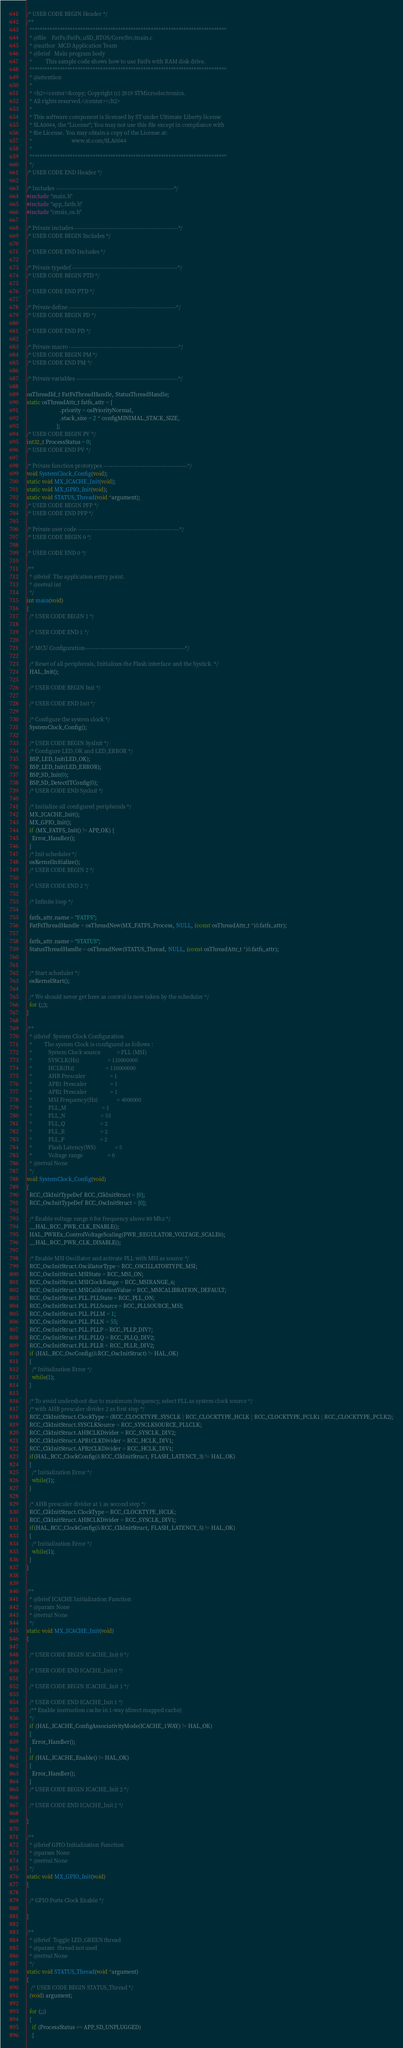<code> <loc_0><loc_0><loc_500><loc_500><_C_>/* USER CODE BEGIN Header */
/**
  ******************************************************************************
  * @file    FatFs/FatFs_uSD_RTOS/Core/Src/main.c
  * @author  MCD Application Team
  * @brief   Main program body
  *          This sample code shows how to use FatFs with RAM disk drive.
  ******************************************************************************
  * @attention
  *
  * <h2><center>&copy; Copyright (c) 2019 STMicroelectronics.
  * All rights reserved.</center></h2>
  *
  * This software component is licensed by ST under Ultimate Liberty license
  * SLA0044, the "License"; You may not use this file except in compliance with
  * the License. You may obtain a copy of the License at:
  *                             www.st.com/SLA0044
  *
  ******************************************************************************
  */
/* USER CODE END Header */

/* Includes ------------------------------------------------------------------*/
#include "main.h"
#include "app_fatfs.h"
#include "cmsis_os.h"

/* Private includes ----------------------------------------------------------*/
/* USER CODE BEGIN Includes */

/* USER CODE END Includes */

/* Private typedef -----------------------------------------------------------*/
/* USER CODE BEGIN PTD */

/* USER CODE END PTD */

/* Private define ------------------------------------------------------------*/
/* USER CODE BEGIN PD */

/* USER CODE END PD */

/* Private macro -------------------------------------------------------------*/
/* USER CODE BEGIN PM */
/* USER CODE END PM */

/* Private variables ---------------------------------------------------------*/

osThreadId_t FatFsThreadHandle, StatusThreadHandle;
static osThreadAttr_t fatfs_attr = {
                        .priority = osPriorityNormal,
                        .stack_size = 2 * configMINIMAL_STACK_SIZE,
                      };
/* USER CODE BEGIN PV */
int32_t ProcessStatus = 0;
/* USER CODE END PV */

/* Private function prototypes -----------------------------------------------*/
void SystemClock_Config(void);
static void MX_ICACHE_Init(void);
static void MX_GPIO_Init(void);
static void STATUS_Thread(void *argument);
/* USER CODE BEGIN PFP */
/* USER CODE END PFP */

/* Private user code ---------------------------------------------------------*/
/* USER CODE BEGIN 0 */

/* USER CODE END 0 */

/**
  * @brief  The application entry point.
  * @retval int
  */
int main(void)
{
  /* USER CODE BEGIN 1 */

  /* USER CODE END 1 */

  /* MCU Configuration--------------------------------------------------------*/

  /* Reset of all peripherals, Initializes the Flash interface and the Systick. */
  HAL_Init();

  /* USER CODE BEGIN Init */

  /* USER CODE END Init */

  /* Configure the system clock */
  SystemClock_Config();

  /* USER CODE BEGIN SysInit */
  /* Configure LED_OK and LED_ERROR */
  BSP_LED_Init(LED_OK);
  BSP_LED_Init(LED_ERROR);
  BSP_SD_Init(0);
  BSP_SD_DetectITConfig(0);
  /* USER CODE END SysInit */

  /* Initialize all configured peripherals */
  MX_ICACHE_Init();
  MX_GPIO_Init();
  if (MX_FATFS_Init() != APP_OK) {
    Error_Handler();
  }
  /* Init scheduler */
  osKernelInitialize();
  /* USER CODE BEGIN 2 */

  /* USER CODE END 2 */

  /* Infinite loop */

  fatfs_attr.name = "FATFS";
  FatFsThreadHandle = osThreadNew(MX_FATFS_Process, NULL, (const osThreadAttr_t *)&fatfs_attr);

  fatfs_attr.name = "STATUS";
  StatusThreadHandle = osThreadNew(STATUS_Thread, NULL, (const osThreadAttr_t *)&fatfs_attr);


  /* Start scheduler */
  osKernelStart();

  /* We should never get here as control is now taken by the scheduler */
  for (;;);
}

/**
  * @brief  System Clock Configuration
  *         The system Clock is configured as follows :
  *            System Clock source            = PLL (MSI)
  *            SYSCLK(Hz)                     = 110000000
  *            HCLK(Hz)                       = 110000000
  *            AHB Prescaler                  = 1
  *            APB1 Prescaler                 = 1
  *            APB2 Prescaler                 = 1
  *            MSI Frequency(Hz)              = 4000000
  *            PLL_M                          = 1
  *            PLL_N                          = 55
  *            PLL_Q                          = 2
  *            PLL_R                          = 2
  *            PLL_P                          = 2
  *            Flash Latency(WS)              = 5
  *            Voltage range                  = 0
  * @retval None
  */
void SystemClock_Config(void)
{
  RCC_ClkInitTypeDef RCC_ClkInitStruct = {0};
  RCC_OscInitTypeDef RCC_OscInitStruct = {0};

  /* Enable voltage range 0 for frequency above 80 Mhz */
  __HAL_RCC_PWR_CLK_ENABLE();
  HAL_PWREx_ControlVoltageScaling(PWR_REGULATOR_VOLTAGE_SCALE0);
  __HAL_RCC_PWR_CLK_DISABLE();

  /* Enable MSI Oscillator and activate PLL with MSI as source */
  RCC_OscInitStruct.OscillatorType = RCC_OSCILLATORTYPE_MSI;
  RCC_OscInitStruct.MSIState = RCC_MSI_ON;
  RCC_OscInitStruct.MSIClockRange = RCC_MSIRANGE_6;
  RCC_OscInitStruct.MSICalibrationValue = RCC_MSICALIBRATION_DEFAULT;
  RCC_OscInitStruct.PLL.PLLState = RCC_PLL_ON;
  RCC_OscInitStruct.PLL.PLLSource = RCC_PLLSOURCE_MSI;
  RCC_OscInitStruct.PLL.PLLM = 1;
  RCC_OscInitStruct.PLL.PLLN = 55;
  RCC_OscInitStruct.PLL.PLLP = RCC_PLLP_DIV7;
  RCC_OscInitStruct.PLL.PLLQ = RCC_PLLQ_DIV2;
  RCC_OscInitStruct.PLL.PLLR = RCC_PLLR_DIV2;
  if (HAL_RCC_OscConfig(&RCC_OscInitStruct) != HAL_OK)
  {
    /* Initialization Error */
    while(1);
  }

  /* To avoid undershoot due to maximum frequency, select PLL as system clock source */
  /* with AHB prescaler divider 2 as first step */
  RCC_ClkInitStruct.ClockType = (RCC_CLOCKTYPE_SYSCLK | RCC_CLOCKTYPE_HCLK | RCC_CLOCKTYPE_PCLK1 | RCC_CLOCKTYPE_PCLK2);
  RCC_ClkInitStruct.SYSCLKSource = RCC_SYSCLKSOURCE_PLLCLK;
  RCC_ClkInitStruct.AHBCLKDivider = RCC_SYSCLK_DIV2;
  RCC_ClkInitStruct.APB1CLKDivider = RCC_HCLK_DIV1;
  RCC_ClkInitStruct.APB2CLKDivider = RCC_HCLK_DIV1;
  if(HAL_RCC_ClockConfig(&RCC_ClkInitStruct, FLASH_LATENCY_3) != HAL_OK)
  {
    /* Initialization Error */
    while(1);
  }

  /* AHB prescaler divider at 1 as second step */
  RCC_ClkInitStruct.ClockType = RCC_CLOCKTYPE_HCLK;
  RCC_ClkInitStruct.AHBCLKDivider = RCC_SYSCLK_DIV1;
  if(HAL_RCC_ClockConfig(&RCC_ClkInitStruct, FLASH_LATENCY_5) != HAL_OK)
  {
    /* Initialization Error */
    while(1);
  }
}


/**
  * @brief ICACHE Initialization Function
  * @param None
  * @retval None
  */
static void MX_ICACHE_Init(void)
{

  /* USER CODE BEGIN ICACHE_Init 0 */

  /* USER CODE END ICACHE_Init 0 */

  /* USER CODE BEGIN ICACHE_Init 1 */

  /* USER CODE END ICACHE_Init 1 */
  /** Enable instruction cache in 1-way (direct mapped cache)
  */
  if (HAL_ICACHE_ConfigAssociativityMode(ICACHE_1WAY) != HAL_OK)
  {
    Error_Handler();
  }
  if (HAL_ICACHE_Enable() != HAL_OK)
  {
    Error_Handler();
  }
  /* USER CODE BEGIN ICACHE_Init 2 */

  /* USER CODE END ICACHE_Init 2 */

}

/**
  * @brief GPIO Initialization Function
  * @param None
  * @retval None
  */
static void MX_GPIO_Init(void)
{

  /* GPIO Ports Clock Enable */

}

/**
  * @brief  Toggle LED_GREEN thread
  * @param  thread not used
  * @retval None
  */
static void STATUS_Thread(void *argument)
{
   /* USER CODE BEGIN STATUS_Thread */
  (void) argument;

  for (;;)
  {
    if (ProcessStatus == APP_SD_UNPLUGGED)
    {</code> 